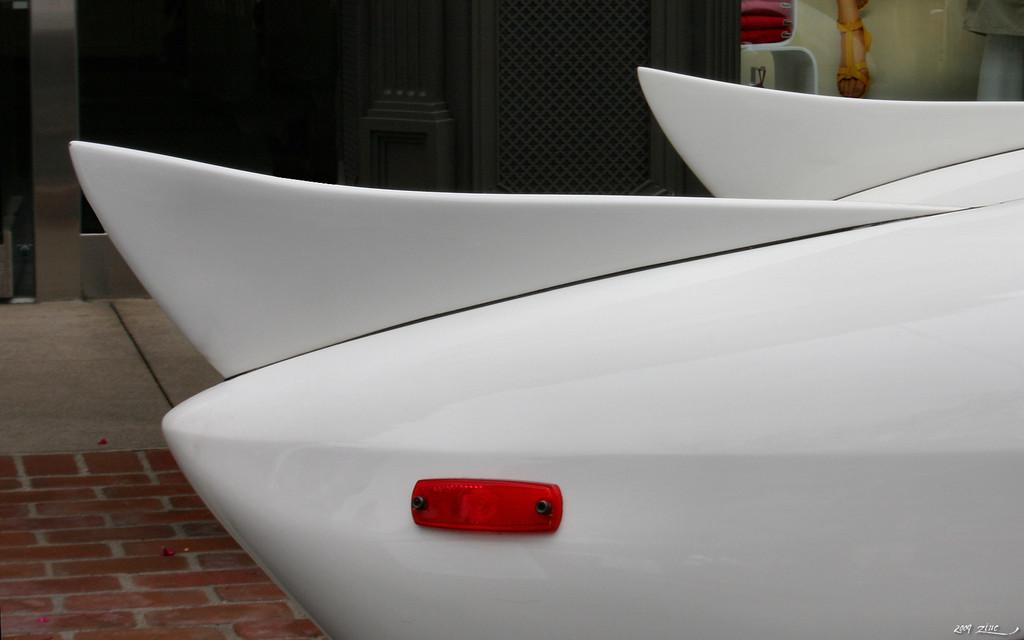What is the main subject of the image? There is a vehicle in the image. Can you describe the position of the vehicle in the image? The vehicle is standing on the ground. What type of pie can be seen hanging from the vehicle in the image? There is no pie present in the image, and therefore no such activity can be observed. 